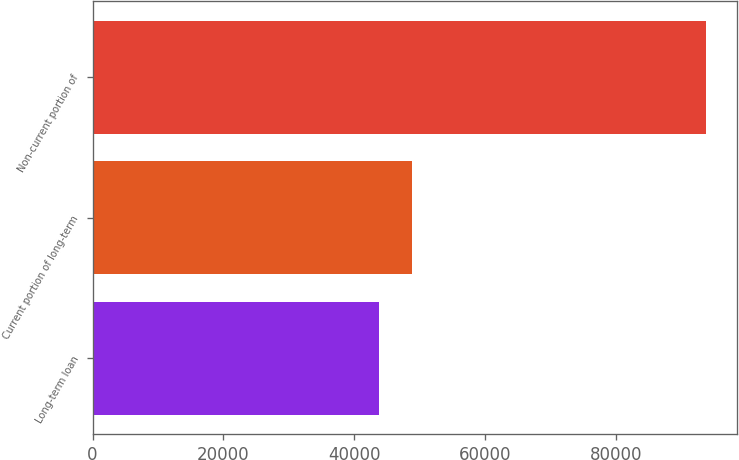Convert chart to OTSL. <chart><loc_0><loc_0><loc_500><loc_500><bar_chart><fcel>Long-term loan<fcel>Current portion of long-term<fcel>Non-current portion of<nl><fcel>43775<fcel>48776.4<fcel>93789<nl></chart> 